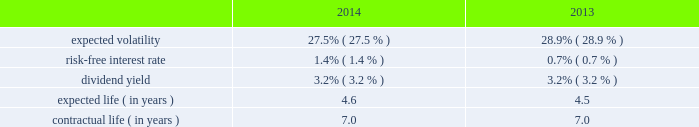Republic services , inc .
Notes to consolidated financial statements 2014 ( continued ) 11 .
Employee benefit plans stock-based compensation in february 2007 , our board of directors approved the 2007 stock incentive plan ( 2007 plan ) , and in may 2007 our shareholders ratified the 2007 plan .
In march 2011 , our board of directors approved the amended and restated 2007 stock incentive plan , and in may 2011 our shareholders ratified the amended and restated 2007 stock incentive plan .
In march 2013 , our board of directors approved the republic services , inc .
Amended and restated 2007 stock incentive plan ( the amended and restated plan ) , and in may 2013 our shareholders ratified the amended and restated plan .
We currently have approximately 15.6 million shares of common stock reserved for future grants under the amended and restated plan .
Options granted under the 2007 plan and the amended and restated plan are non-qualified and are granted at a price equal to the fair market value of our common stock at the date of grant .
Generally , options granted have a term of seven to ten years from the date of grant , and vest in increments of 25% ( 25 % ) per year over a period of four years beginning on the first anniversary date of the grant .
Options granted to non-employee directors have a term of ten years and are fully vested at the grant date .
In december 2008 , the board of directors amended and restated the republic services , inc .
2006 incentive stock plan ( formerly known as the allied waste industries , inc .
2006 incentive stock plan ) ( the 2006 plan ) .
Allied 2019s shareholders approved the 2006 plan in may 2006 .
The 2006 plan was amended and restated in december 2008 to reflect republic as the new sponsor of the plan , to reflect that any references to shares of common stock are to shares of common stock of republic , and to adjust outstanding awards and the number of shares available under the plan to reflect the allied acquisition .
The 2006 plan , as amended and restated , provided for the grant of non- qualified stock options , incentive stock options , shares of restricted stock , shares of phantom stock , stock bonuses , restricted stock units , stock appreciation rights , performance awards , dividend equivalents , cash awards , or other stock-based awards .
Awards granted under the 2006 plan prior to december 5 , 2008 became fully vested and nonforfeitable upon the closing of the allied acquisition .
No further awards will be made under the 2006 stock options we use a lattice binomial option-pricing model to value our stock option grants .
We recognize compensation expense on a straight-line basis over the requisite service period for each separately vesting portion of the award , or to the employee 2019s retirement eligible date , if earlier .
Expected volatility is based on the weighted average of the most recent one year volatility and a historical rolling average volatility of our stock over the expected life of the option .
The risk-free interest rate is based on federal reserve rates in effect for bonds with maturity dates equal to the expected term of the option .
We use historical data to estimate future option exercises , forfeitures ( at 3.0% ( 3.0 % ) for 2014 and 2013 ) and expected life of the options .
When appropriate , separate groups of employees that have similar historical exercise behavior are considered separately for valuation purposes .
We did not grant stock options during the year ended december 31 , 2015 .
The weighted-average estimated fair values of stock options granted during the years ended december 31 , 2014 and 2013 were $ 5.74 and $ 5.27 per option , respectively , which were calculated using the following weighted-average assumptions: .

What was the percent of decline in the expected volatility from 2013 to 2014? 
Rationale: the percent of decline in the expected volatility from 2013 to 2014 was 4.84%
Computations: ((27.5 - 28.9) / 28.9)
Answer: -0.04844. 